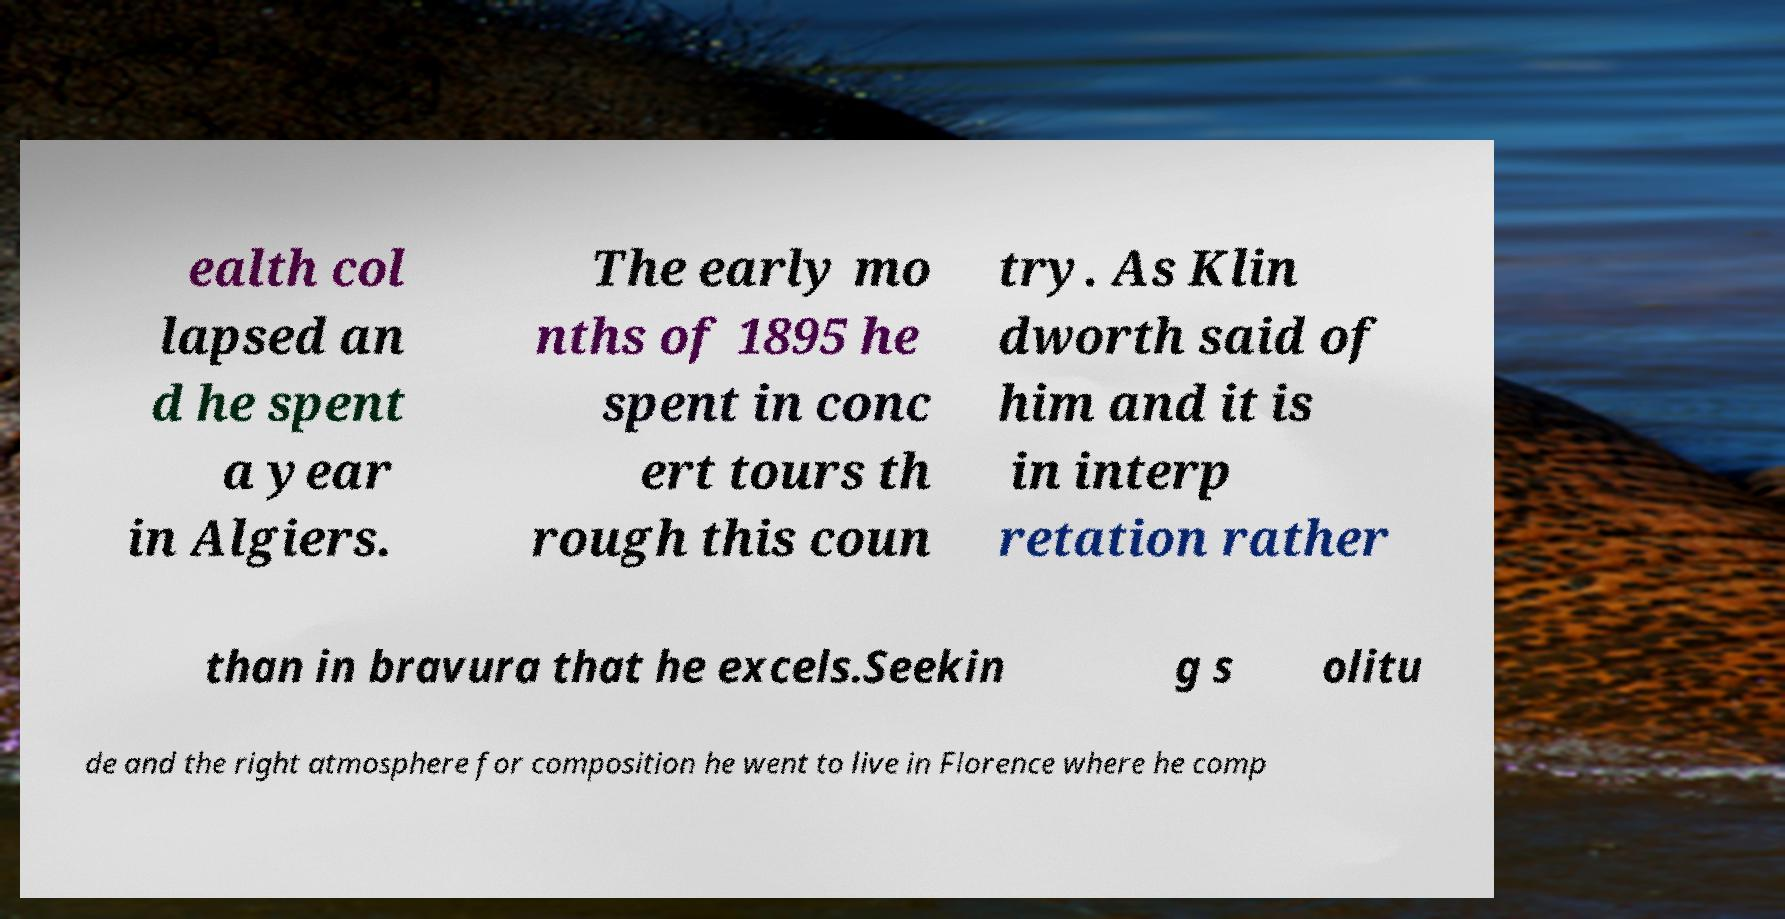Please read and relay the text visible in this image. What does it say? ealth col lapsed an d he spent a year in Algiers. The early mo nths of 1895 he spent in conc ert tours th rough this coun try. As Klin dworth said of him and it is in interp retation rather than in bravura that he excels.Seekin g s olitu de and the right atmosphere for composition he went to live in Florence where he comp 